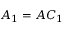<formula> <loc_0><loc_0><loc_500><loc_500>A _ { 1 } = A C _ { 1 }</formula> 